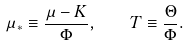Convert formula to latex. <formula><loc_0><loc_0><loc_500><loc_500>\mu _ { * } \equiv \frac { \mu - K } { \Phi } , \quad T \equiv \frac { \Theta } { \Phi } .</formula> 